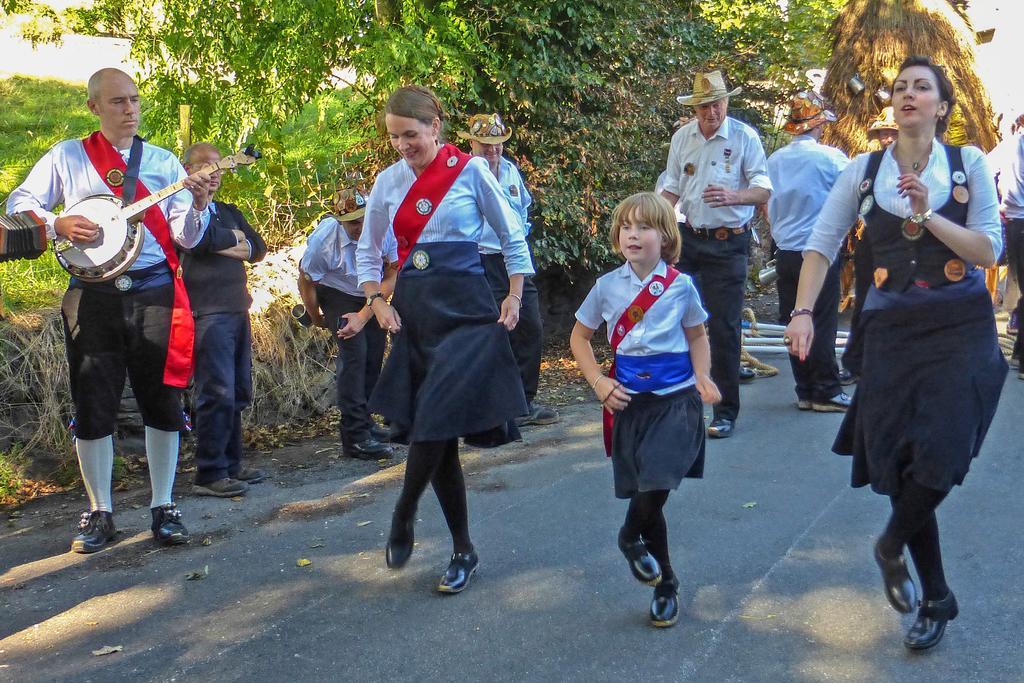Describe this image in one or two sentences. In this image we can see few people dancing on a road and a person on the left side is playing a musical instrument and there are trees in the background. 